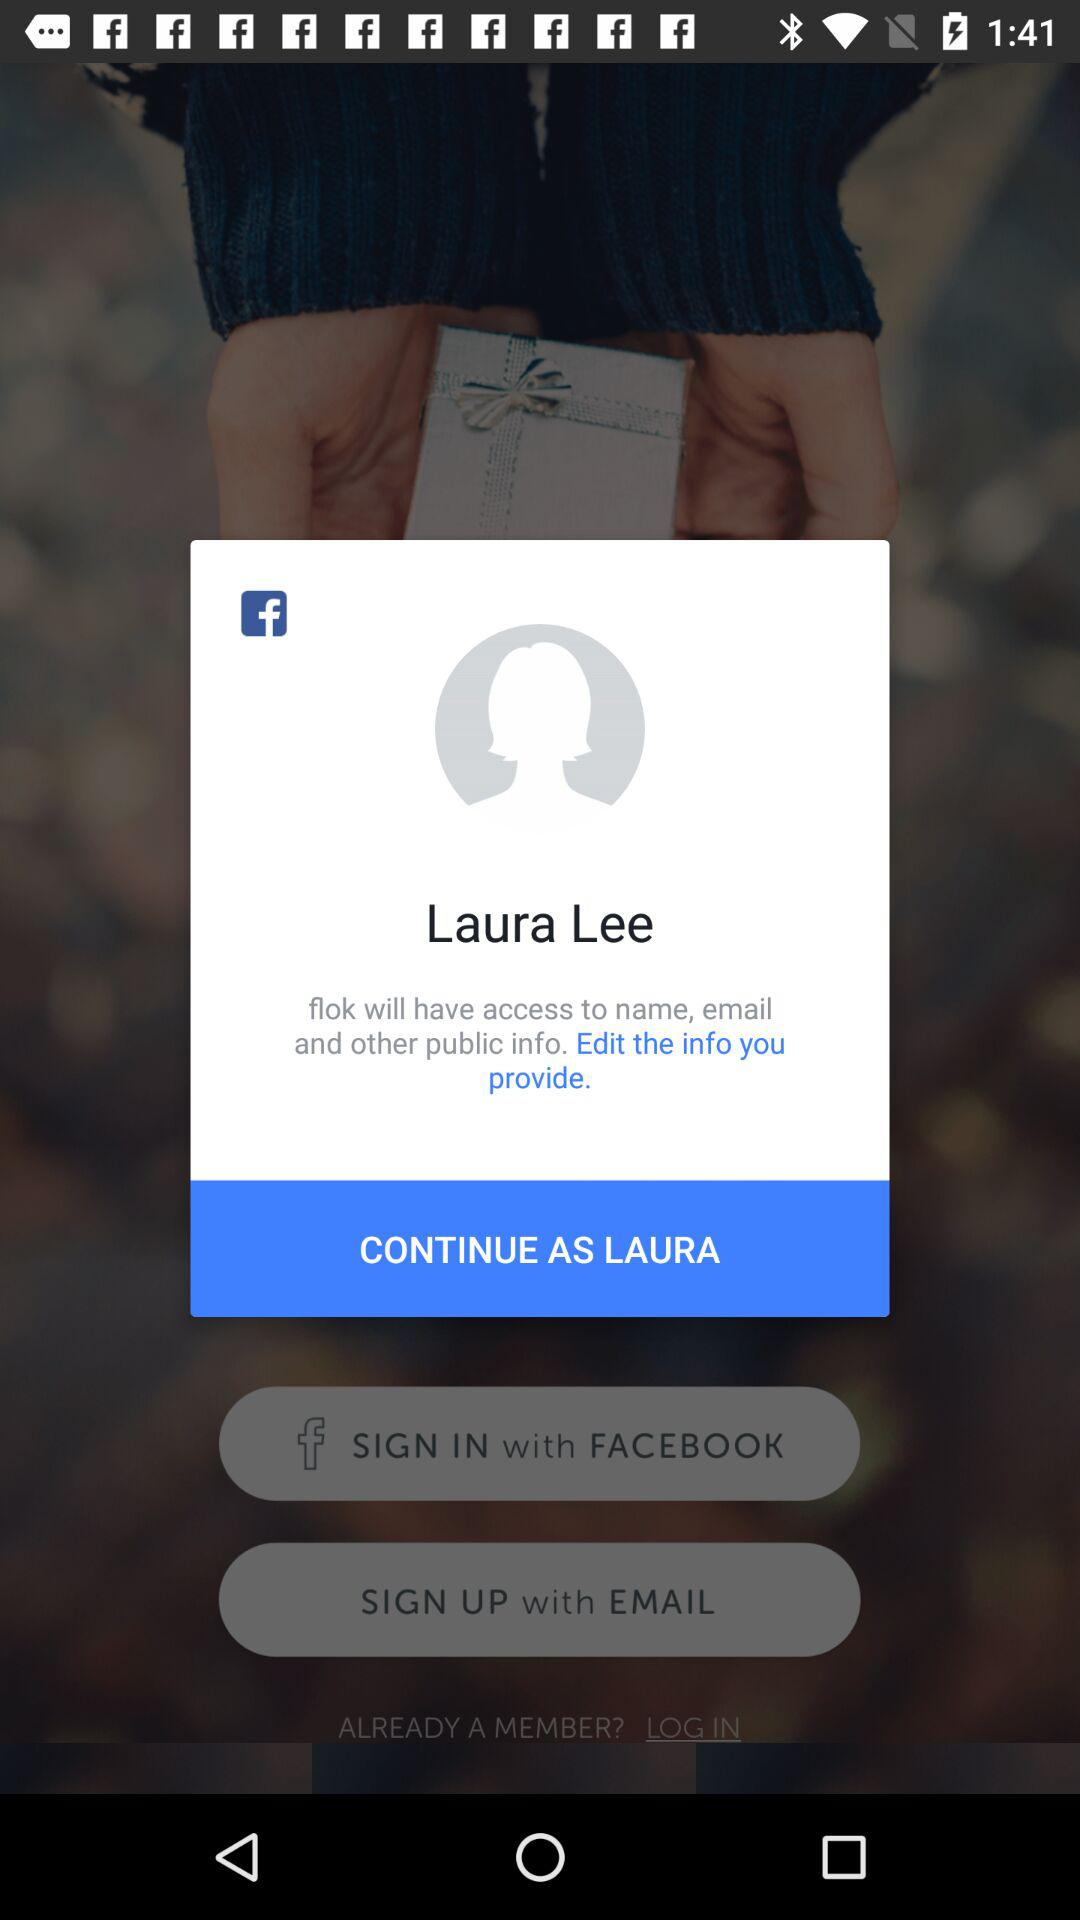What is the name of the user? The name of the user is Laura Lee. 